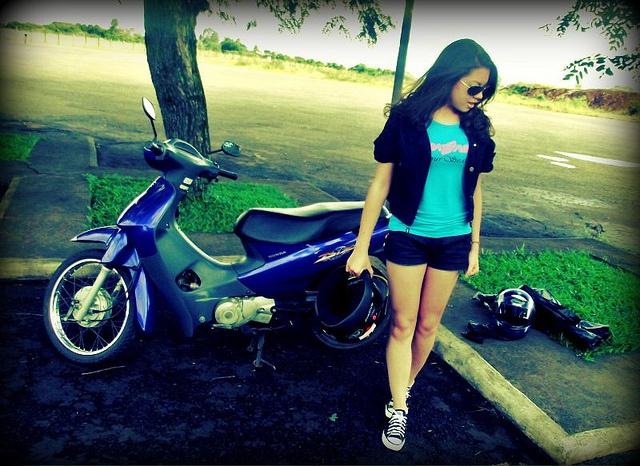Describe the objects in this image and their specific colors. I can see motorcycle in black, navy, blue, and beige tones and people in black, navy, turquoise, and tan tones in this image. 